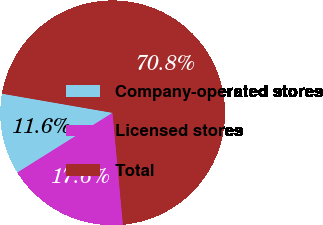Convert chart to OTSL. <chart><loc_0><loc_0><loc_500><loc_500><pie_chart><fcel>Company-operated stores<fcel>Licensed stores<fcel>Total<nl><fcel>11.65%<fcel>17.56%<fcel>70.79%<nl></chart> 